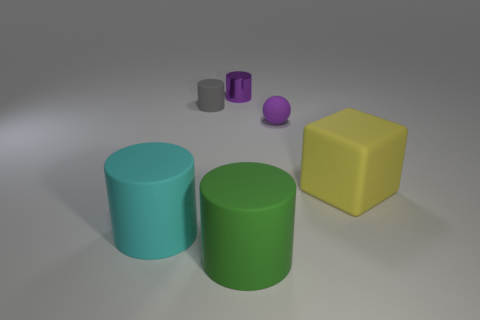Is there any other thing that has the same material as the purple cylinder?
Provide a succinct answer. No. Is there anything else that has the same shape as the large yellow object?
Keep it short and to the point. No. Are there more cylinders behind the purple matte thing than large green things in front of the gray matte cylinder?
Provide a short and direct response. Yes. There is a cyan matte thing that is behind the green thing; how many purple metal cylinders are in front of it?
Your answer should be very brief. 0. How many things are either small purple metallic cubes or gray matte cylinders?
Give a very brief answer. 1. Is the cyan object the same shape as the big yellow thing?
Your answer should be very brief. No. What is the material of the large green object?
Your answer should be very brief. Rubber. How many tiny objects are right of the gray matte cylinder and in front of the shiny cylinder?
Provide a short and direct response. 1. Do the gray rubber thing and the cyan matte cylinder have the same size?
Offer a very short reply. No. There is a purple thing in front of the gray object; does it have the same size as the cyan cylinder?
Your answer should be very brief. No. 